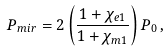Convert formula to latex. <formula><loc_0><loc_0><loc_500><loc_500>P _ { m i r } = 2 \left ( \frac { 1 + \chi _ { e 1 } } { 1 + \chi _ { m 1 } } \right ) P _ { 0 } \, ,</formula> 